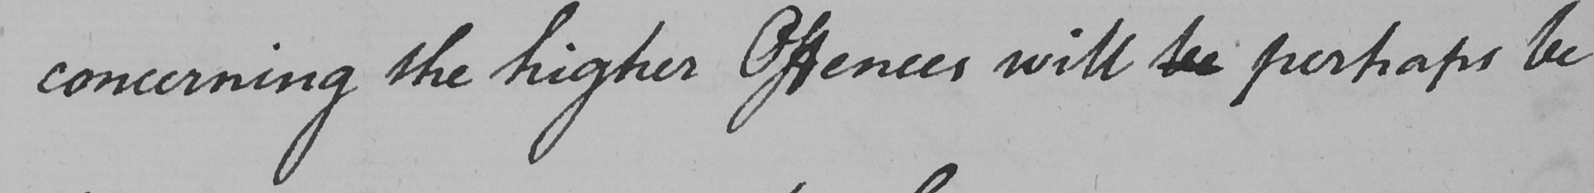Can you tell me what this handwritten text says? concerning the higher Offences will be perhaps be 